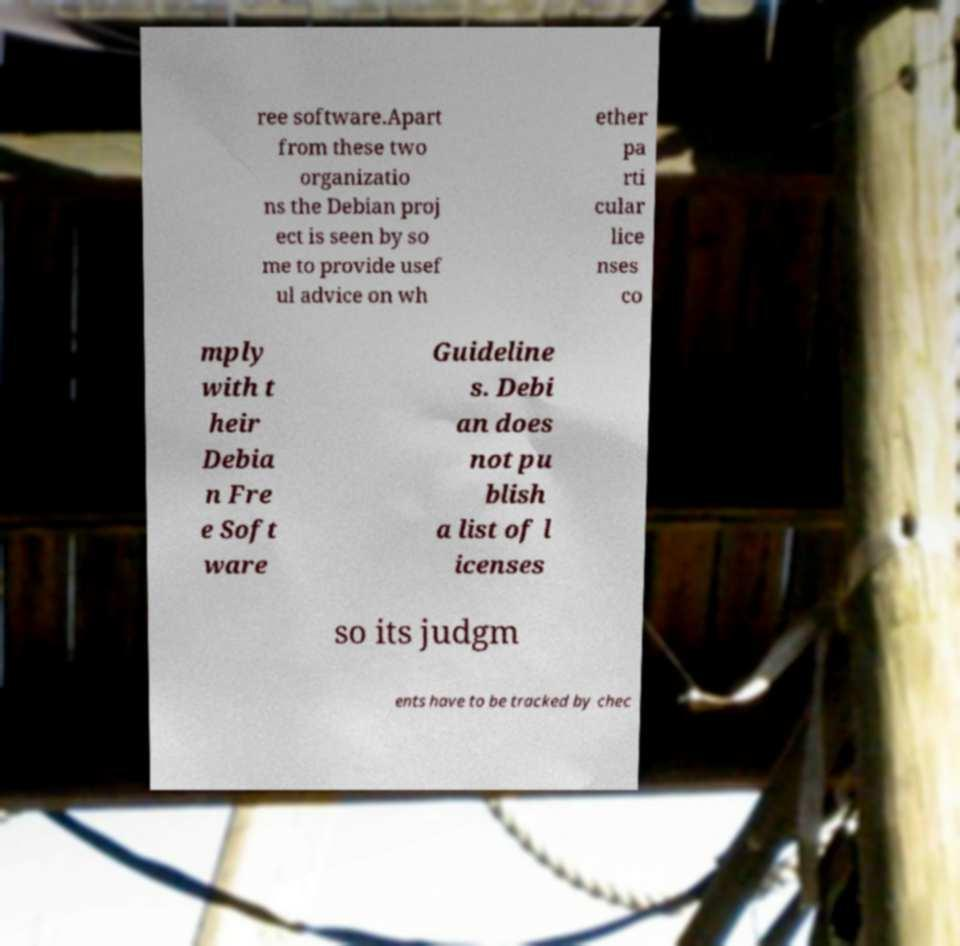Please read and relay the text visible in this image. What does it say? ree software.Apart from these two organizatio ns the Debian proj ect is seen by so me to provide usef ul advice on wh ether pa rti cular lice nses co mply with t heir Debia n Fre e Soft ware Guideline s. Debi an does not pu blish a list of l icenses so its judgm ents have to be tracked by chec 